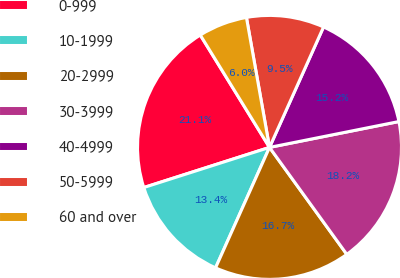Convert chart. <chart><loc_0><loc_0><loc_500><loc_500><pie_chart><fcel>0-999<fcel>10-1999<fcel>20-2999<fcel>30-3999<fcel>40-4999<fcel>50-5999<fcel>60 and over<nl><fcel>21.13%<fcel>13.38%<fcel>16.66%<fcel>18.18%<fcel>15.15%<fcel>9.51%<fcel>5.99%<nl></chart> 